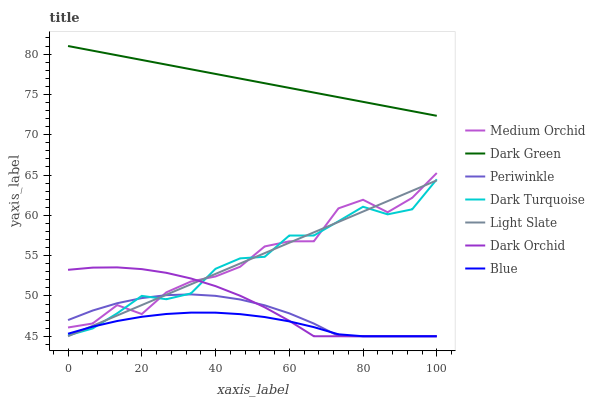Does Blue have the minimum area under the curve?
Answer yes or no. Yes. Does Dark Green have the maximum area under the curve?
Answer yes or no. Yes. Does Light Slate have the minimum area under the curve?
Answer yes or no. No. Does Light Slate have the maximum area under the curve?
Answer yes or no. No. Is Light Slate the smoothest?
Answer yes or no. Yes. Is Medium Orchid the roughest?
Answer yes or no. Yes. Is Dark Turquoise the smoothest?
Answer yes or no. No. Is Dark Turquoise the roughest?
Answer yes or no. No. Does Dark Turquoise have the lowest value?
Answer yes or no. No. Does Dark Green have the highest value?
Answer yes or no. Yes. Does Light Slate have the highest value?
Answer yes or no. No. Is Dark Orchid less than Dark Green?
Answer yes or no. Yes. Is Dark Green greater than Dark Orchid?
Answer yes or no. Yes. Does Medium Orchid intersect Dark Turquoise?
Answer yes or no. Yes. Is Medium Orchid less than Dark Turquoise?
Answer yes or no. No. Is Medium Orchid greater than Dark Turquoise?
Answer yes or no. No. Does Dark Orchid intersect Dark Green?
Answer yes or no. No. 